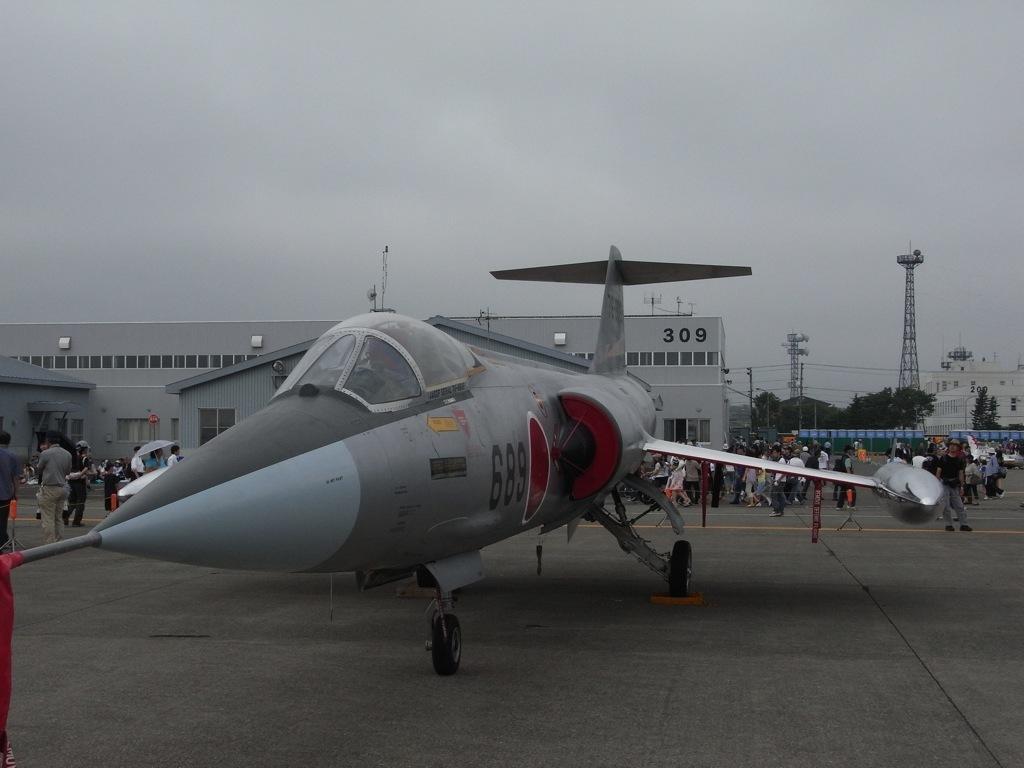Describe this image in one or two sentences. In the picture we can see an aircraft which is placed on the path and in the background, we can see many people are walking and behind them, we can see a building and beside it, we can see some trees, towers, and some other buildings and behind it we can see a sky. 